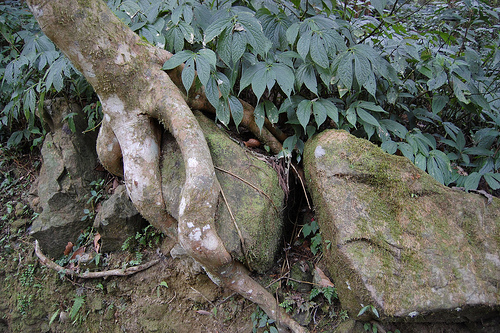<image>
Can you confirm if the rock is to the right of the tree? Yes. From this viewpoint, the rock is positioned to the right side relative to the tree. 